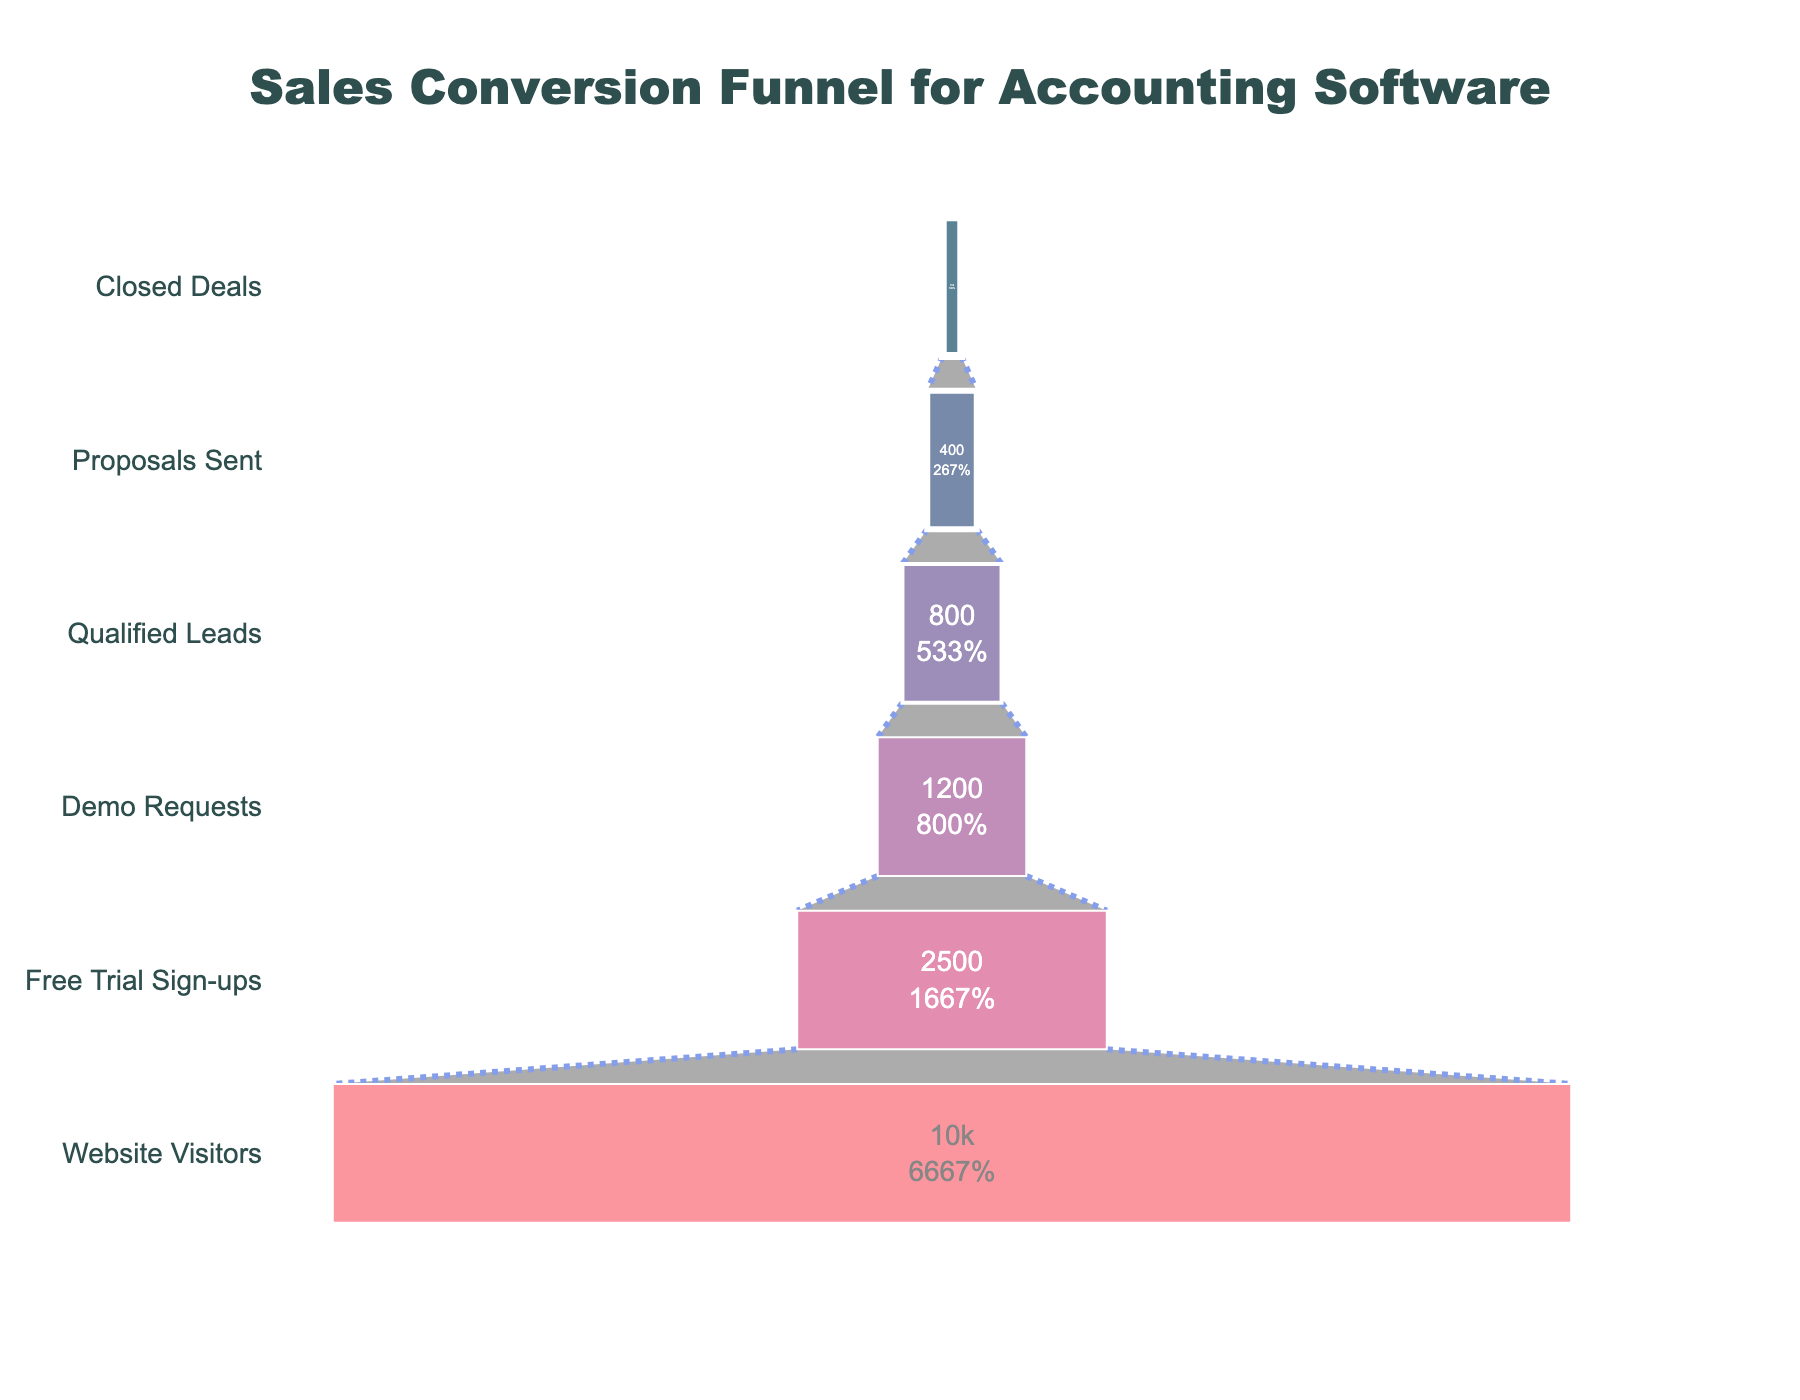what is the total number of prospects at the beginning of the sales funnel? The funnel chart starts with "Website Visitors" at the top. According to the data provided, the number of website visitors is 10,000.
Answer: 10,000 How many prospects sign up for the free trial? The second stage in the funnel is "Free Trial Sign-ups." The number of prospects for this stage is indicated as 2,500 in the figure.
Answer: 2,500 What percentage of the initial prospects become closed deals? To find this percentage, divide the number of closed deals (150) by the initial number of prospects (10,000) and multiply by 100. (150 / 10,000) * 100 = 1.5%
Answer: 1.5% How many more demo requests are there compared to qualified leads? The number of demo requests is 1,200 and the number of qualified leads is 800. Subtract the number of qualified leads from the demo requests. 1,200 - 800 = 400
Answer: 400 Rank the stages in the sales funnel based on the number of prospects from highest to lowest. The stages based on the number of prospects are: Website Visitors (10,000), Free Trial Sign-ups (2,500), Demo Requests (1,200), Qualified Leads (800), Proposals Sent (400), Closed Deals (150).
Answer: Website Visitors > Free Trial Sign-ups > Demo Requests > Qualified Leads > Proposals Sent > Closed Deals At which stage do we see the largest drop in the number of prospects? By comparing each stage, the largest drop in number is from Website Visitors (10,000) to Free Trial Sign-ups (2,500), a drop of 7,500.
Answer: From Website Visitors to Free Trial Sign-ups Calculate the probability of a qualified lead turning into a closed deal. The number of qualified leads is 800, and the number of closed deals is 150. The probability is calculated as 150 / 800 = 0.1875, which is 18.75%.
Answer: 18.75% How much shrinkage is observed from the Free Trial Sign-ups stage to the Qualified Leads stage? Starting from Free Trial Sign-ups (2,500), the number of Qualified Leads is 800. The shrinkage is found by subtracting 800 from 2,500, which equals 1,700.
Answer: 1,700 Which stage has the smallest number of prospects, and how many? The Closed Deals stage has the smallest number of prospects, with 150 prospects.
Answer: Closed Deals, 150 